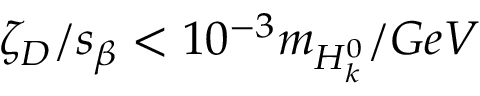Convert formula to latex. <formula><loc_0><loc_0><loc_500><loc_500>\zeta _ { D } / s _ { \beta } < 1 0 ^ { - 3 } m _ { H _ { k } ^ { 0 } } / G e V</formula> 